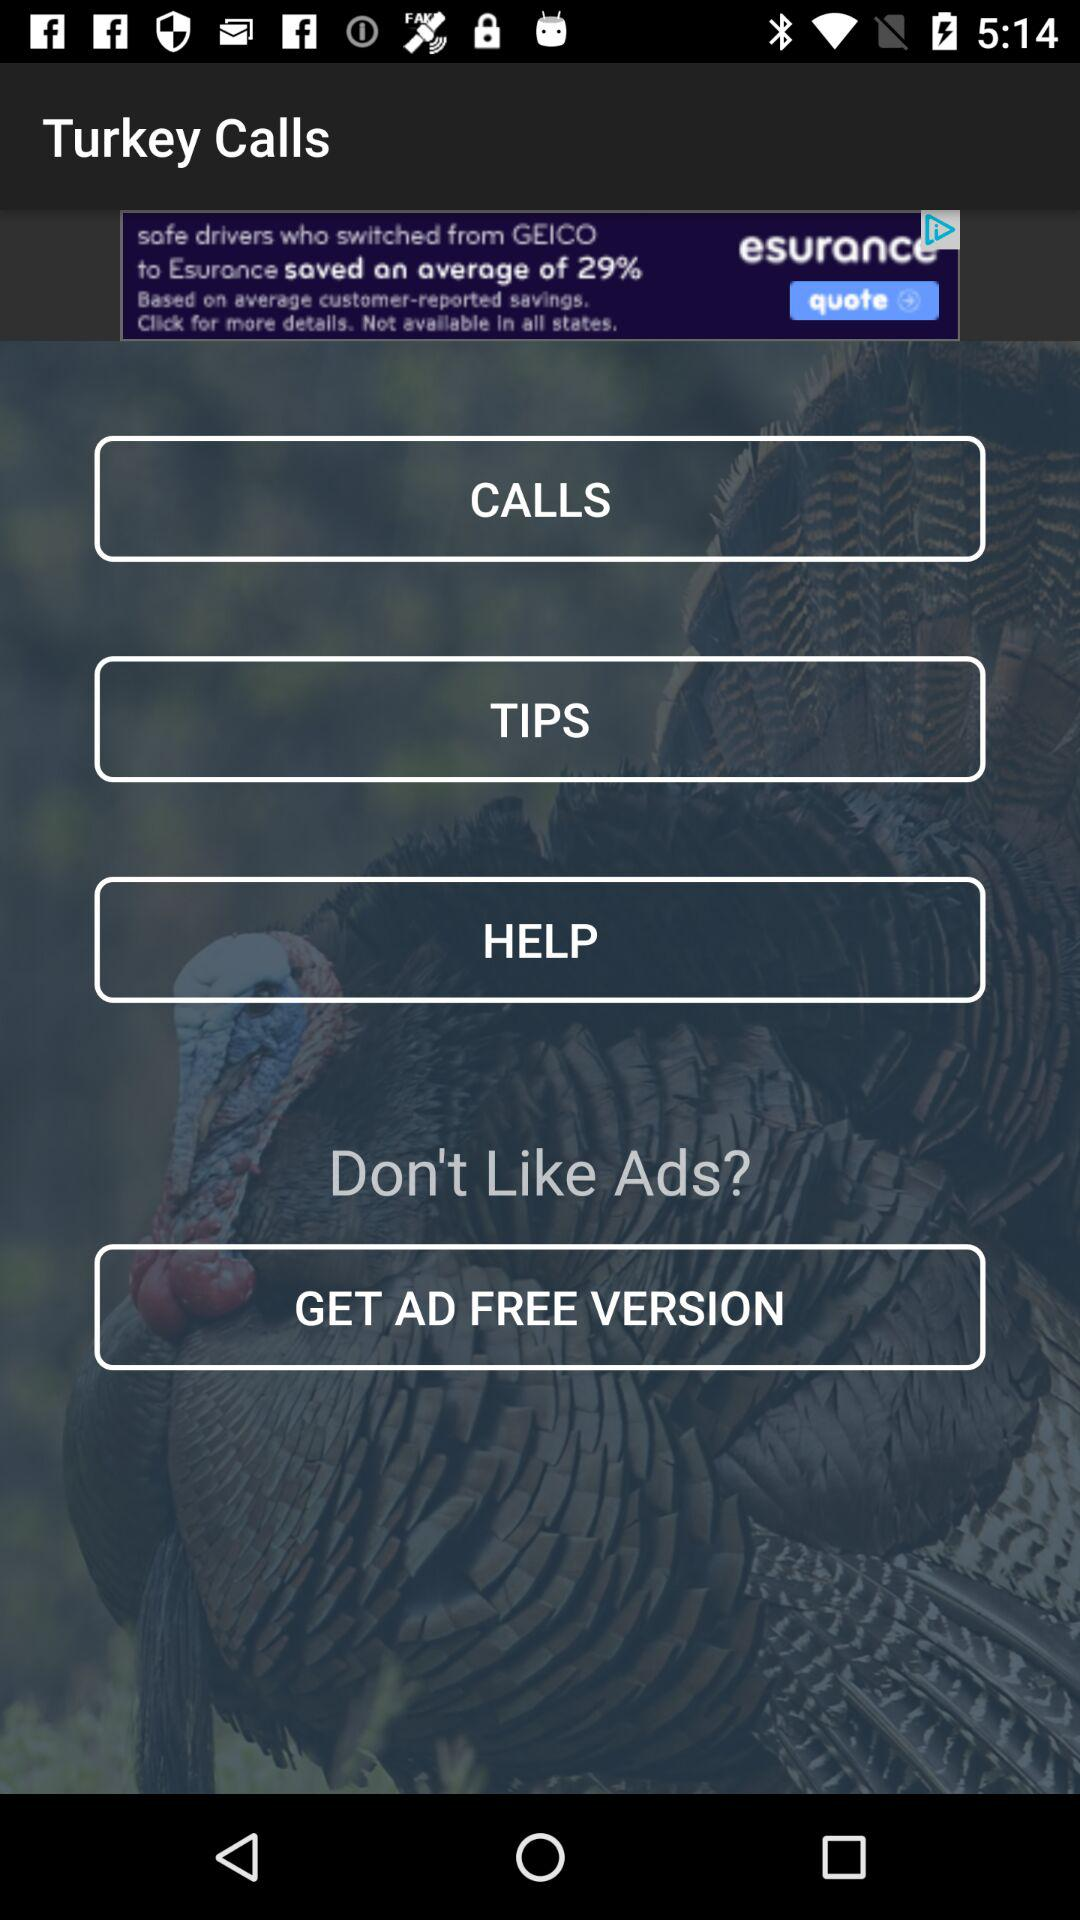What is the name of the application? The name of the application is "Turkey Calls". 